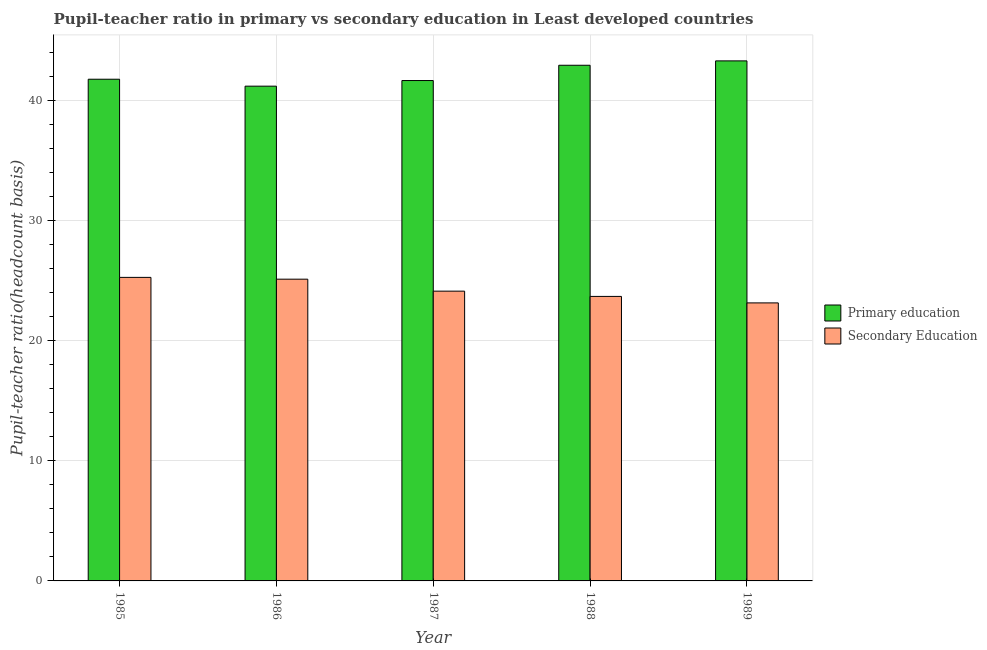How many groups of bars are there?
Your answer should be very brief. 5. Are the number of bars per tick equal to the number of legend labels?
Provide a short and direct response. Yes. Are the number of bars on each tick of the X-axis equal?
Your answer should be compact. Yes. How many bars are there on the 1st tick from the right?
Offer a terse response. 2. What is the label of the 3rd group of bars from the left?
Your answer should be very brief. 1987. What is the pupil teacher ratio on secondary education in 1989?
Provide a succinct answer. 23.16. Across all years, what is the maximum pupil teacher ratio on secondary education?
Offer a terse response. 25.28. Across all years, what is the minimum pupil-teacher ratio in primary education?
Your answer should be compact. 41.21. In which year was the pupil-teacher ratio in primary education maximum?
Keep it short and to the point. 1989. What is the total pupil-teacher ratio in primary education in the graph?
Offer a terse response. 210.95. What is the difference between the pupil-teacher ratio in primary education in 1986 and that in 1988?
Provide a succinct answer. -1.74. What is the difference between the pupil teacher ratio on secondary education in 1988 and the pupil-teacher ratio in primary education in 1985?
Offer a terse response. -1.59. What is the average pupil-teacher ratio in primary education per year?
Make the answer very short. 42.19. What is the ratio of the pupil teacher ratio on secondary education in 1985 to that in 1987?
Your answer should be compact. 1.05. Is the pupil-teacher ratio in primary education in 1985 less than that in 1987?
Provide a succinct answer. No. What is the difference between the highest and the second highest pupil teacher ratio on secondary education?
Your answer should be compact. 0.15. What is the difference between the highest and the lowest pupil teacher ratio on secondary education?
Your response must be concise. 2.13. Is the sum of the pupil-teacher ratio in primary education in 1986 and 1987 greater than the maximum pupil teacher ratio on secondary education across all years?
Offer a terse response. Yes. What does the 2nd bar from the left in 1988 represents?
Your answer should be compact. Secondary Education. What does the 2nd bar from the right in 1989 represents?
Offer a terse response. Primary education. Are all the bars in the graph horizontal?
Your answer should be compact. No. How many years are there in the graph?
Provide a succinct answer. 5. Where does the legend appear in the graph?
Make the answer very short. Center right. How are the legend labels stacked?
Offer a terse response. Vertical. What is the title of the graph?
Your answer should be very brief. Pupil-teacher ratio in primary vs secondary education in Least developed countries. What is the label or title of the Y-axis?
Give a very brief answer. Pupil-teacher ratio(headcount basis). What is the Pupil-teacher ratio(headcount basis) of Primary education in 1985?
Make the answer very short. 41.79. What is the Pupil-teacher ratio(headcount basis) in Secondary Education in 1985?
Make the answer very short. 25.28. What is the Pupil-teacher ratio(headcount basis) of Primary education in 1986?
Ensure brevity in your answer.  41.21. What is the Pupil-teacher ratio(headcount basis) of Secondary Education in 1986?
Provide a short and direct response. 25.13. What is the Pupil-teacher ratio(headcount basis) in Primary education in 1987?
Provide a succinct answer. 41.68. What is the Pupil-teacher ratio(headcount basis) in Secondary Education in 1987?
Ensure brevity in your answer.  24.14. What is the Pupil-teacher ratio(headcount basis) in Primary education in 1988?
Your answer should be compact. 42.95. What is the Pupil-teacher ratio(headcount basis) of Secondary Education in 1988?
Make the answer very short. 23.7. What is the Pupil-teacher ratio(headcount basis) of Primary education in 1989?
Give a very brief answer. 43.32. What is the Pupil-teacher ratio(headcount basis) of Secondary Education in 1989?
Keep it short and to the point. 23.16. Across all years, what is the maximum Pupil-teacher ratio(headcount basis) in Primary education?
Make the answer very short. 43.32. Across all years, what is the maximum Pupil-teacher ratio(headcount basis) in Secondary Education?
Provide a short and direct response. 25.28. Across all years, what is the minimum Pupil-teacher ratio(headcount basis) in Primary education?
Provide a succinct answer. 41.21. Across all years, what is the minimum Pupil-teacher ratio(headcount basis) in Secondary Education?
Make the answer very short. 23.16. What is the total Pupil-teacher ratio(headcount basis) of Primary education in the graph?
Offer a terse response. 210.95. What is the total Pupil-teacher ratio(headcount basis) in Secondary Education in the graph?
Keep it short and to the point. 121.41. What is the difference between the Pupil-teacher ratio(headcount basis) in Primary education in 1985 and that in 1986?
Offer a very short reply. 0.58. What is the difference between the Pupil-teacher ratio(headcount basis) in Secondary Education in 1985 and that in 1986?
Provide a short and direct response. 0.15. What is the difference between the Pupil-teacher ratio(headcount basis) of Primary education in 1985 and that in 1987?
Offer a terse response. 0.11. What is the difference between the Pupil-teacher ratio(headcount basis) in Secondary Education in 1985 and that in 1987?
Provide a short and direct response. 1.15. What is the difference between the Pupil-teacher ratio(headcount basis) in Primary education in 1985 and that in 1988?
Make the answer very short. -1.16. What is the difference between the Pupil-teacher ratio(headcount basis) of Secondary Education in 1985 and that in 1988?
Your answer should be very brief. 1.59. What is the difference between the Pupil-teacher ratio(headcount basis) of Primary education in 1985 and that in 1989?
Make the answer very short. -1.53. What is the difference between the Pupil-teacher ratio(headcount basis) of Secondary Education in 1985 and that in 1989?
Make the answer very short. 2.13. What is the difference between the Pupil-teacher ratio(headcount basis) in Primary education in 1986 and that in 1987?
Keep it short and to the point. -0.47. What is the difference between the Pupil-teacher ratio(headcount basis) of Primary education in 1986 and that in 1988?
Ensure brevity in your answer.  -1.74. What is the difference between the Pupil-teacher ratio(headcount basis) in Secondary Education in 1986 and that in 1988?
Provide a short and direct response. 1.44. What is the difference between the Pupil-teacher ratio(headcount basis) of Primary education in 1986 and that in 1989?
Your answer should be compact. -2.11. What is the difference between the Pupil-teacher ratio(headcount basis) in Secondary Education in 1986 and that in 1989?
Make the answer very short. 1.98. What is the difference between the Pupil-teacher ratio(headcount basis) in Primary education in 1987 and that in 1988?
Provide a succinct answer. -1.27. What is the difference between the Pupil-teacher ratio(headcount basis) of Secondary Education in 1987 and that in 1988?
Ensure brevity in your answer.  0.44. What is the difference between the Pupil-teacher ratio(headcount basis) in Primary education in 1987 and that in 1989?
Your answer should be very brief. -1.64. What is the difference between the Pupil-teacher ratio(headcount basis) of Secondary Education in 1987 and that in 1989?
Offer a very short reply. 0.98. What is the difference between the Pupil-teacher ratio(headcount basis) in Primary education in 1988 and that in 1989?
Make the answer very short. -0.37. What is the difference between the Pupil-teacher ratio(headcount basis) of Secondary Education in 1988 and that in 1989?
Your response must be concise. 0.54. What is the difference between the Pupil-teacher ratio(headcount basis) of Primary education in 1985 and the Pupil-teacher ratio(headcount basis) of Secondary Education in 1986?
Your answer should be compact. 16.65. What is the difference between the Pupil-teacher ratio(headcount basis) of Primary education in 1985 and the Pupil-teacher ratio(headcount basis) of Secondary Education in 1987?
Make the answer very short. 17.65. What is the difference between the Pupil-teacher ratio(headcount basis) of Primary education in 1985 and the Pupil-teacher ratio(headcount basis) of Secondary Education in 1988?
Provide a succinct answer. 18.09. What is the difference between the Pupil-teacher ratio(headcount basis) in Primary education in 1985 and the Pupil-teacher ratio(headcount basis) in Secondary Education in 1989?
Provide a short and direct response. 18.63. What is the difference between the Pupil-teacher ratio(headcount basis) of Primary education in 1986 and the Pupil-teacher ratio(headcount basis) of Secondary Education in 1987?
Give a very brief answer. 17.07. What is the difference between the Pupil-teacher ratio(headcount basis) in Primary education in 1986 and the Pupil-teacher ratio(headcount basis) in Secondary Education in 1988?
Make the answer very short. 17.51. What is the difference between the Pupil-teacher ratio(headcount basis) of Primary education in 1986 and the Pupil-teacher ratio(headcount basis) of Secondary Education in 1989?
Keep it short and to the point. 18.05. What is the difference between the Pupil-teacher ratio(headcount basis) in Primary education in 1987 and the Pupil-teacher ratio(headcount basis) in Secondary Education in 1988?
Make the answer very short. 17.98. What is the difference between the Pupil-teacher ratio(headcount basis) of Primary education in 1987 and the Pupil-teacher ratio(headcount basis) of Secondary Education in 1989?
Ensure brevity in your answer.  18.52. What is the difference between the Pupil-teacher ratio(headcount basis) in Primary education in 1988 and the Pupil-teacher ratio(headcount basis) in Secondary Education in 1989?
Give a very brief answer. 19.79. What is the average Pupil-teacher ratio(headcount basis) of Primary education per year?
Provide a short and direct response. 42.19. What is the average Pupil-teacher ratio(headcount basis) in Secondary Education per year?
Offer a terse response. 24.28. In the year 1985, what is the difference between the Pupil-teacher ratio(headcount basis) of Primary education and Pupil-teacher ratio(headcount basis) of Secondary Education?
Give a very brief answer. 16.5. In the year 1986, what is the difference between the Pupil-teacher ratio(headcount basis) of Primary education and Pupil-teacher ratio(headcount basis) of Secondary Education?
Offer a very short reply. 16.08. In the year 1987, what is the difference between the Pupil-teacher ratio(headcount basis) in Primary education and Pupil-teacher ratio(headcount basis) in Secondary Education?
Make the answer very short. 17.54. In the year 1988, what is the difference between the Pupil-teacher ratio(headcount basis) of Primary education and Pupil-teacher ratio(headcount basis) of Secondary Education?
Your response must be concise. 19.25. In the year 1989, what is the difference between the Pupil-teacher ratio(headcount basis) of Primary education and Pupil-teacher ratio(headcount basis) of Secondary Education?
Provide a succinct answer. 20.16. What is the ratio of the Pupil-teacher ratio(headcount basis) of Secondary Education in 1985 to that in 1986?
Your answer should be compact. 1.01. What is the ratio of the Pupil-teacher ratio(headcount basis) of Primary education in 1985 to that in 1987?
Provide a short and direct response. 1. What is the ratio of the Pupil-teacher ratio(headcount basis) in Secondary Education in 1985 to that in 1987?
Offer a terse response. 1.05. What is the ratio of the Pupil-teacher ratio(headcount basis) in Primary education in 1985 to that in 1988?
Give a very brief answer. 0.97. What is the ratio of the Pupil-teacher ratio(headcount basis) of Secondary Education in 1985 to that in 1988?
Offer a terse response. 1.07. What is the ratio of the Pupil-teacher ratio(headcount basis) of Primary education in 1985 to that in 1989?
Offer a very short reply. 0.96. What is the ratio of the Pupil-teacher ratio(headcount basis) of Secondary Education in 1985 to that in 1989?
Provide a succinct answer. 1.09. What is the ratio of the Pupil-teacher ratio(headcount basis) in Primary education in 1986 to that in 1987?
Offer a very short reply. 0.99. What is the ratio of the Pupil-teacher ratio(headcount basis) in Secondary Education in 1986 to that in 1987?
Offer a terse response. 1.04. What is the ratio of the Pupil-teacher ratio(headcount basis) in Primary education in 1986 to that in 1988?
Make the answer very short. 0.96. What is the ratio of the Pupil-teacher ratio(headcount basis) of Secondary Education in 1986 to that in 1988?
Keep it short and to the point. 1.06. What is the ratio of the Pupil-teacher ratio(headcount basis) of Primary education in 1986 to that in 1989?
Offer a terse response. 0.95. What is the ratio of the Pupil-teacher ratio(headcount basis) of Secondary Education in 1986 to that in 1989?
Offer a terse response. 1.09. What is the ratio of the Pupil-teacher ratio(headcount basis) in Primary education in 1987 to that in 1988?
Ensure brevity in your answer.  0.97. What is the ratio of the Pupil-teacher ratio(headcount basis) of Secondary Education in 1987 to that in 1988?
Keep it short and to the point. 1.02. What is the ratio of the Pupil-teacher ratio(headcount basis) of Primary education in 1987 to that in 1989?
Provide a short and direct response. 0.96. What is the ratio of the Pupil-teacher ratio(headcount basis) of Secondary Education in 1987 to that in 1989?
Your answer should be compact. 1.04. What is the ratio of the Pupil-teacher ratio(headcount basis) in Primary education in 1988 to that in 1989?
Your answer should be very brief. 0.99. What is the ratio of the Pupil-teacher ratio(headcount basis) of Secondary Education in 1988 to that in 1989?
Make the answer very short. 1.02. What is the difference between the highest and the second highest Pupil-teacher ratio(headcount basis) in Primary education?
Offer a very short reply. 0.37. What is the difference between the highest and the second highest Pupil-teacher ratio(headcount basis) of Secondary Education?
Make the answer very short. 0.15. What is the difference between the highest and the lowest Pupil-teacher ratio(headcount basis) in Primary education?
Make the answer very short. 2.11. What is the difference between the highest and the lowest Pupil-teacher ratio(headcount basis) of Secondary Education?
Your response must be concise. 2.13. 